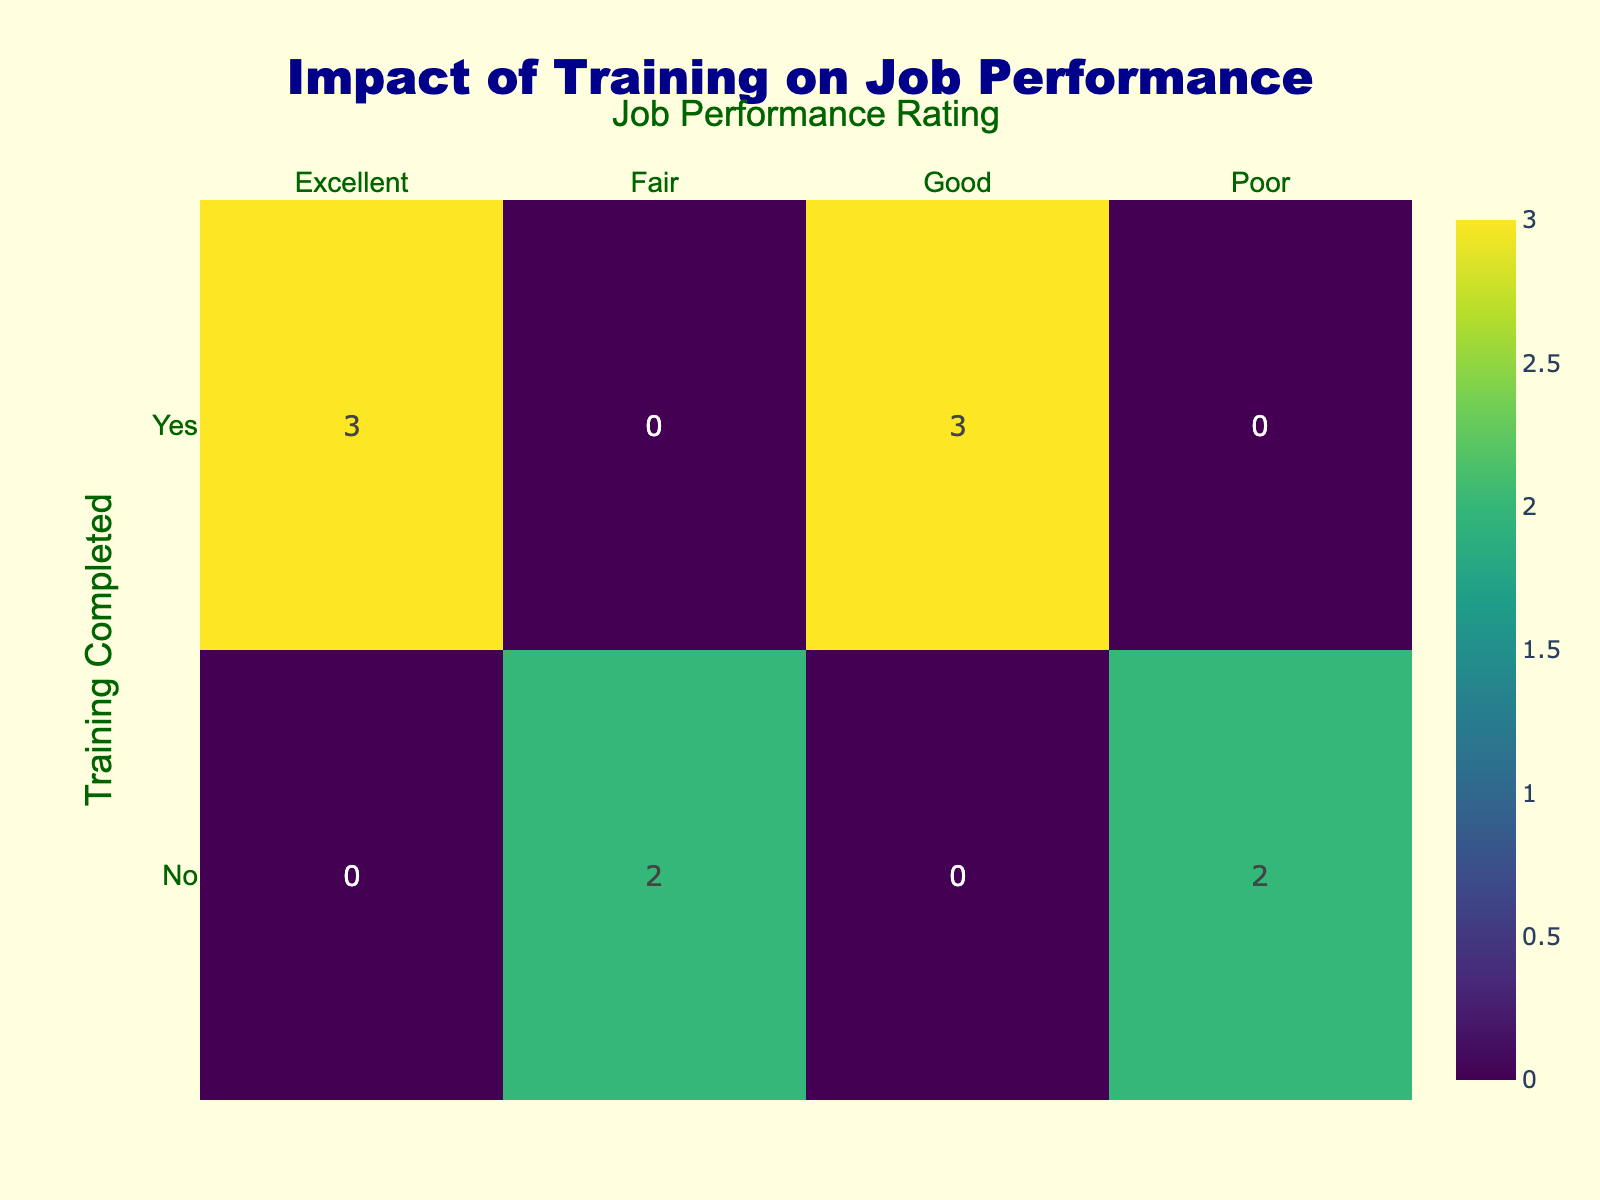What is the total number of employees who completed training? Looking at the "TrainingCompleted" row in the table, we see three categories: "Yes" and "No". The "Yes" row indicates a total of 6 employees who completed training.
Answer: 6 What is the number of employees with an "Excellent" job performance rating? By observing the table, we see the "Excellent" category in the "JobPerformanceRating" column, which intersects with both training completed (Yes) and No. There are 3 employees in total with an "Excellent" rating, all of whom completed training.
Answer: 3 How many employees did not complete training and received a "Poor" job performance rating? Looking at the "No" row under "TrainingCompleted" and finding the "Poor" rating in the "JobPerformanceRating" column, we identify 2 employees who fall into this category.
Answer: 2 Is the statement "All employees who completed training have good job performance ratings" true or false? To determine this, we check all ratings in the "Yes" row for "TrainingCompleted". We find that one employee received a "Fair" rating, which makes the statement false.
Answer: False What is the difference in the number of employees rated as "Good" between those who completed training and those who did not? From the "Good" ratings, we see 3 employees who completed training and 0 who did not. Therefore, the difference is 3 (3 - 0 = 3).
Answer: 3 What percentage of trained employees received an "Excellent" performance rating? There are 6 trained employees, out of which 3 received an "Excellent" rating. To find the percentage, we calculate (3/6)*100 which results in 50%.
Answer: 50% What is the promotion eligibility status of employees with a "Fair" job performance rating? In the table, both employees with the "Fair" rating (who did not complete training) are not eligible for promotion, which corresponds to a "No" in the respective column.
Answer: No How many total employees are eligible for promotion? To find the total eligible for promotion, we need to count all "Yes" in the "PromotionEligibility" column. Checking the entries, we see 4 employees are eligible for promotion.
Answer: 4 What proportion of employees who completed training received either "Good" or "Excellent" job performance ratings? Among the trained employees (6 total), 5 achieved either "Good" (3) or "Excellent" (3) ratings. The proportion is found by dividing the count of these ratings by the total trained, which results in 5/6, or approximately 83.33%.
Answer: 83.33% 